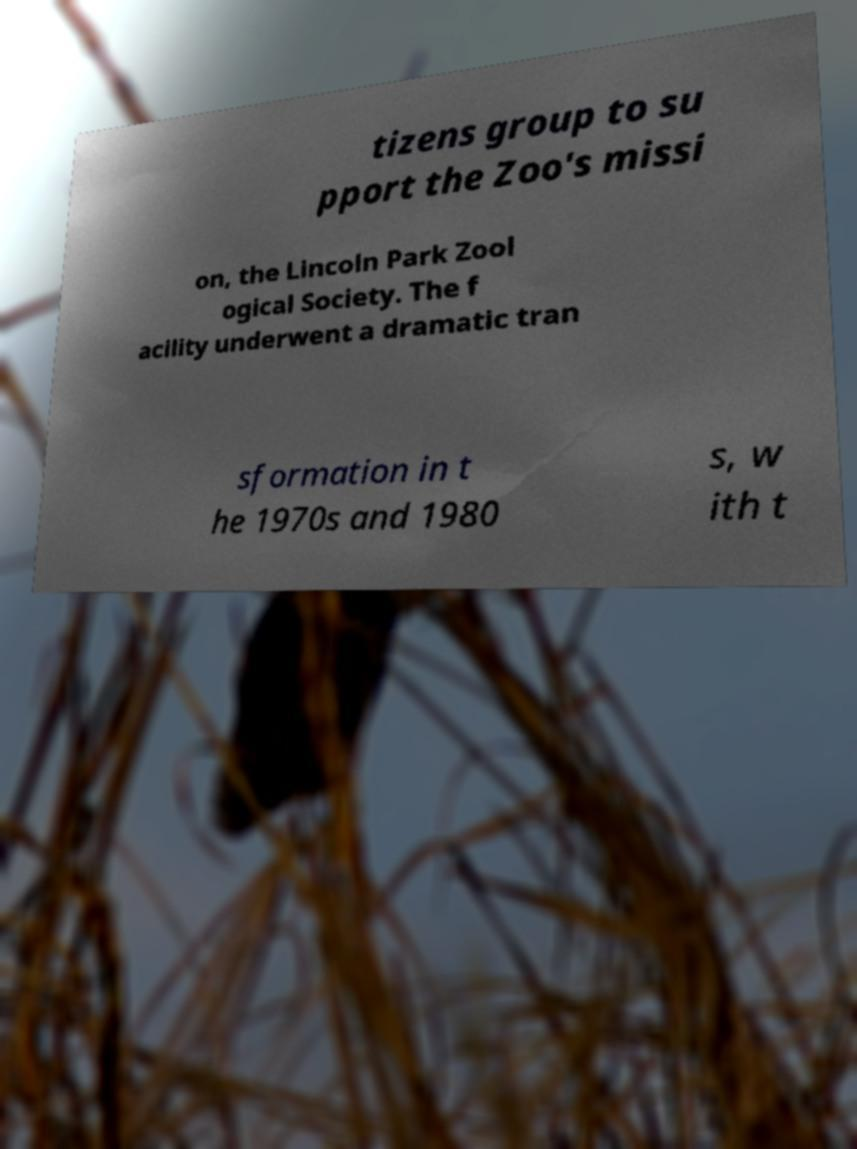What messages or text are displayed in this image? I need them in a readable, typed format. tizens group to su pport the Zoo's missi on, the Lincoln Park Zool ogical Society. The f acility underwent a dramatic tran sformation in t he 1970s and 1980 s, w ith t 